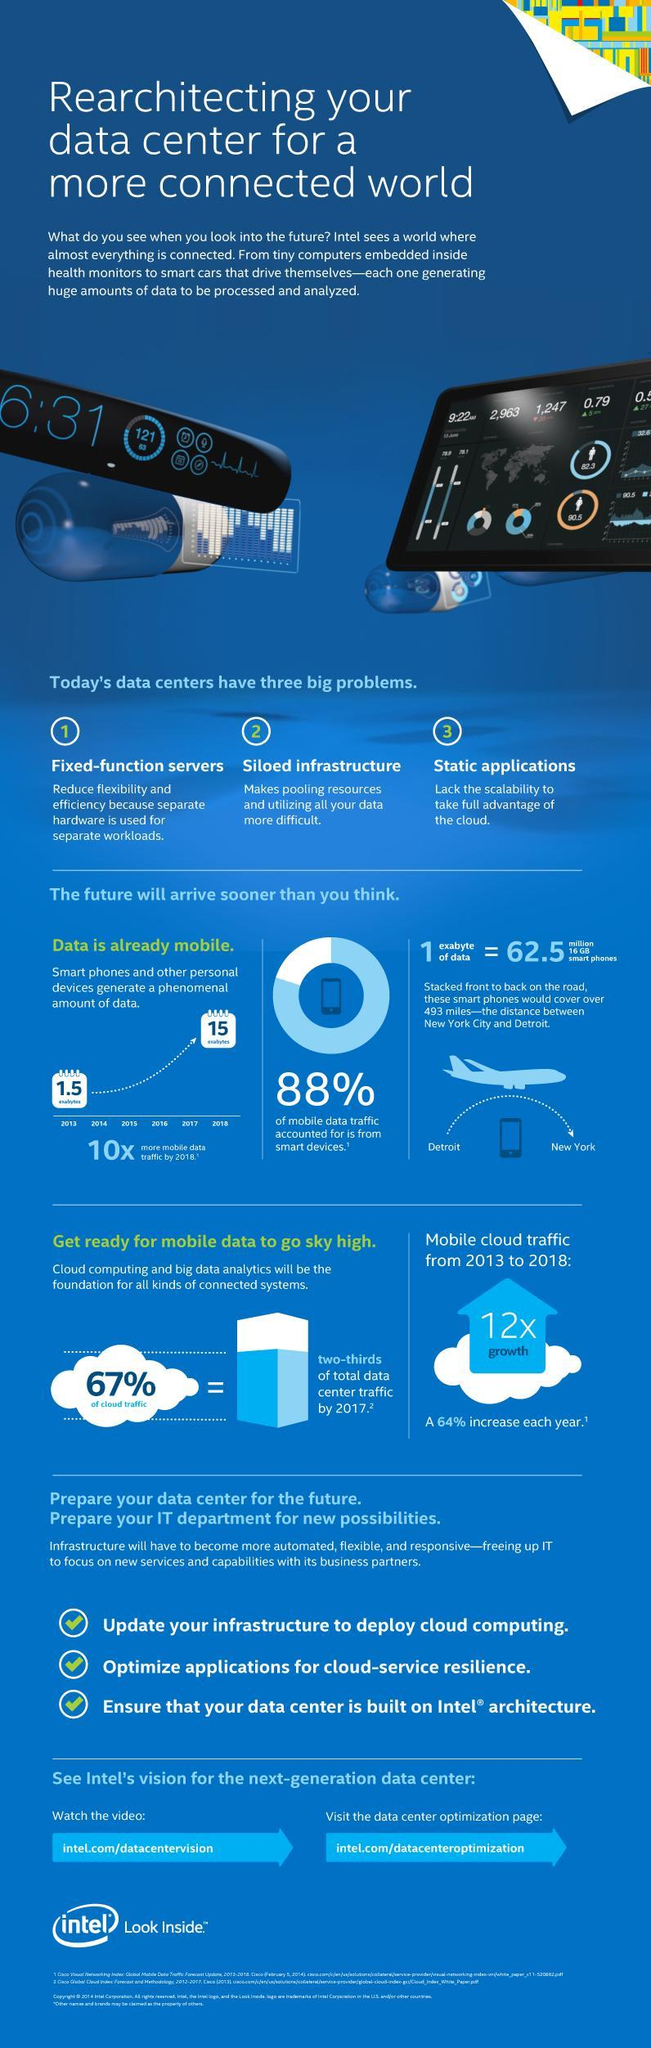What percentage of mobile data traffic is not from smart devices?
Answer the question with a short phrase. 12% What is the percentage of cloud traffic? 33% 